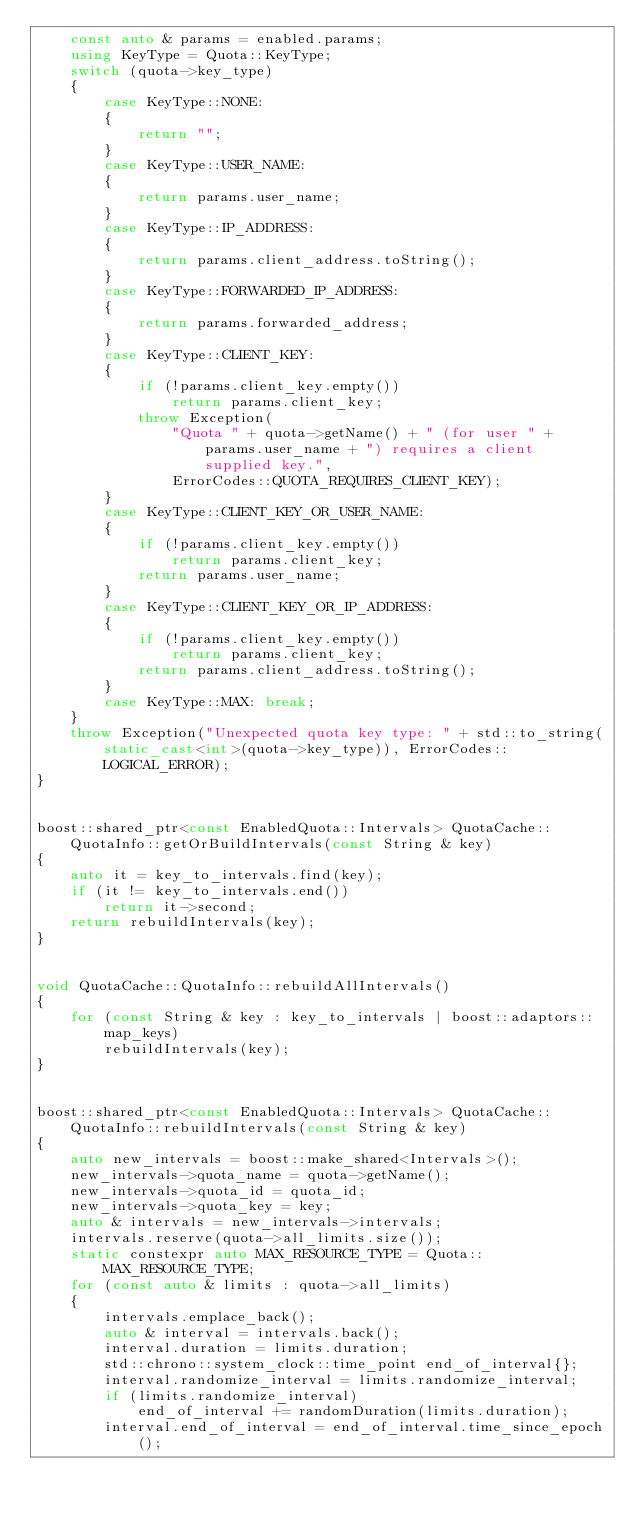<code> <loc_0><loc_0><loc_500><loc_500><_C++_>    const auto & params = enabled.params;
    using KeyType = Quota::KeyType;
    switch (quota->key_type)
    {
        case KeyType::NONE:
        {
            return "";
        }
        case KeyType::USER_NAME:
        {
            return params.user_name;
        }
        case KeyType::IP_ADDRESS:
        {
            return params.client_address.toString();
        }
        case KeyType::FORWARDED_IP_ADDRESS:
        {
            return params.forwarded_address;
        }
        case KeyType::CLIENT_KEY:
        {
            if (!params.client_key.empty())
                return params.client_key;
            throw Exception(
                "Quota " + quota->getName() + " (for user " + params.user_name + ") requires a client supplied key.",
                ErrorCodes::QUOTA_REQUIRES_CLIENT_KEY);
        }
        case KeyType::CLIENT_KEY_OR_USER_NAME:
        {
            if (!params.client_key.empty())
                return params.client_key;
            return params.user_name;
        }
        case KeyType::CLIENT_KEY_OR_IP_ADDRESS:
        {
            if (!params.client_key.empty())
                return params.client_key;
            return params.client_address.toString();
        }
        case KeyType::MAX: break;
    }
    throw Exception("Unexpected quota key type: " + std::to_string(static_cast<int>(quota->key_type)), ErrorCodes::LOGICAL_ERROR);
}


boost::shared_ptr<const EnabledQuota::Intervals> QuotaCache::QuotaInfo::getOrBuildIntervals(const String & key)
{
    auto it = key_to_intervals.find(key);
    if (it != key_to_intervals.end())
        return it->second;
    return rebuildIntervals(key);
}


void QuotaCache::QuotaInfo::rebuildAllIntervals()
{
    for (const String & key : key_to_intervals | boost::adaptors::map_keys)
        rebuildIntervals(key);
}


boost::shared_ptr<const EnabledQuota::Intervals> QuotaCache::QuotaInfo::rebuildIntervals(const String & key)
{
    auto new_intervals = boost::make_shared<Intervals>();
    new_intervals->quota_name = quota->getName();
    new_intervals->quota_id = quota_id;
    new_intervals->quota_key = key;
    auto & intervals = new_intervals->intervals;
    intervals.reserve(quota->all_limits.size());
    static constexpr auto MAX_RESOURCE_TYPE = Quota::MAX_RESOURCE_TYPE;
    for (const auto & limits : quota->all_limits)
    {
        intervals.emplace_back();
        auto & interval = intervals.back();
        interval.duration = limits.duration;
        std::chrono::system_clock::time_point end_of_interval{};
        interval.randomize_interval = limits.randomize_interval;
        if (limits.randomize_interval)
            end_of_interval += randomDuration(limits.duration);
        interval.end_of_interval = end_of_interval.time_since_epoch();</code> 